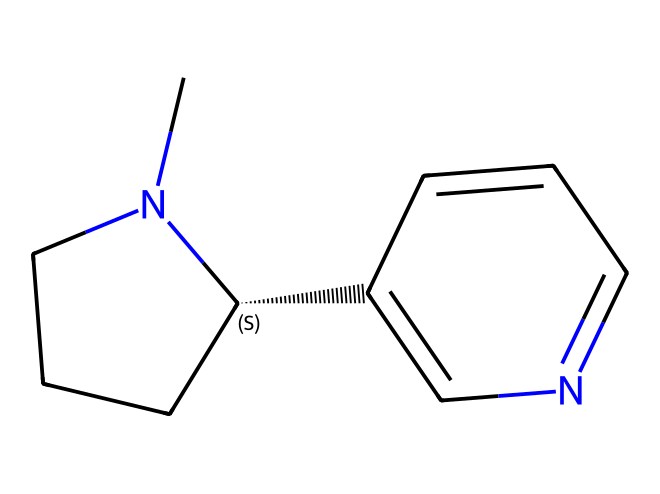What is the total number of carbon atoms in the structure? By examining the SMILES notation, we can identify the number of carbon atoms. Each 'C' in the code represents a carbon atom. Counting each 'C' present, we find there are 10 carbon atoms in total.
Answer: ten How many nitrogen atoms are present in the compound? In the given SMILES notation, each 'N' represents a nitrogen atom. There are two 'N's in the structure. Thus, there are two nitrogen atoms in total.
Answer: two What is the degree of saturation of this compound? The degree of saturation can be determined by analyzing the number of hydrogen atoms in correlation with carbon and nitrogen. Each carbon typically bonds to enough hydrogen to satisfy its tetravalency. However, in this case, there are nitrogen atoms which can also affect bonding. The structure indicates saturation points which leads to a calculated degree of saturation of 3.
Answer: three Is this compound a ring structure? The presence of square brackets and cyclic connectivity suggests that it incorporates ring structures. Specifically, we can see the connectivity that allows for cyclic arrangements, confirming this is indeed a ring compound.
Answer: yes What type of compound is this based on its functional groups? The notable presence of nitrogen atoms in the ring and the structure suggests that it is an alkaloid, more specifically a heterocyclic compound due to the integration of nitrogen in a cyclic arrangement.
Answer: alkaloid How many double bonds are present in the structure? By analyzing the SMILES we can evaluate whether there are multiple bonds. The '=' symbol denotes double bonds. In the given structure, there's only one occurrence of the '=' symbol, indicating one double bond is present.
Answer: one What characteristic feature of this compound may relate to tobacco's effects? The presence of nitrogen and the general structure reveales that this compound is an alkaloid, a type known for its pharmacological effects, closely related to nicotine found in tobacco, giving it potential stimulant properties.
Answer: alkaloid 